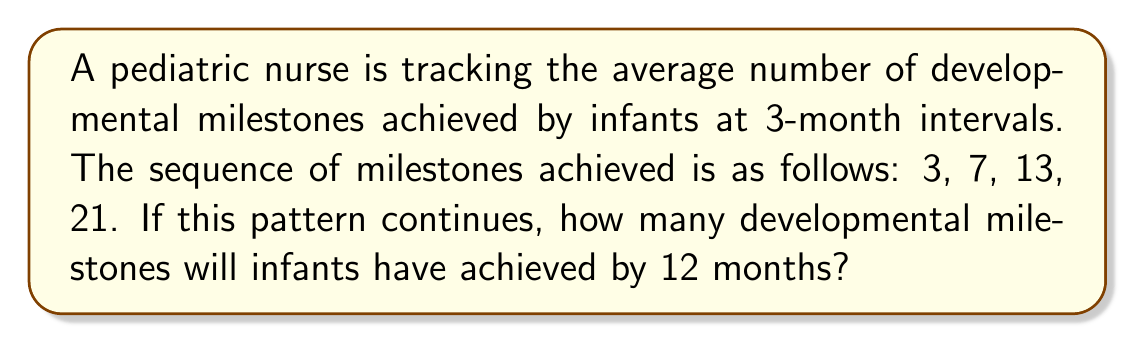Can you answer this question? To solve this problem, we need to analyze the pattern in the given sequence and extend it to the 12-month mark. Let's break it down step-by-step:

1. Given sequence: 3, 7, 13, 21
   This represents milestones at 0, 3, 6, and 9 months.

2. Find the difference between consecutive terms:
   $7 - 3 = 4$
   $13 - 7 = 6$
   $21 - 13 = 8$

3. We can see that the difference is increasing by 2 each time:
   $4, 6, 8$

4. This suggests a quadratic sequence. The general form of a quadratic sequence is:
   $a_n = an^2 + bn + c$

5. To find $a$, $b$, and $c$, we can use the first three terms:
   $3 = a(0)^2 + b(0) + c$
   $7 = a(1)^2 + b(1) + c$
   $13 = a(2)^2 + b(2) + c$

6. Solving this system of equations:
   $c = 3$
   $a + b + 3 = 7$
   $4a + 2b + 3 = 13$

7. Subtracting the second equation from the third:
   $3a + b = 6$
   $a + b = 4$
   $2a = 2$
   $a = 1$

8. Substituting back:
   $1 + b = 4$
   $b = 3$

9. Therefore, the sequence follows the formula:
   $a_n = n^2 + 3n + 3$

10. For 12 months, we need the 5th term (n = 4):
    $a_4 = 4^2 + 3(4) + 3 = 16 + 12 + 3 = 31$

Thus, infants will have achieved 31 developmental milestones by 12 months.
Answer: 31 milestones 